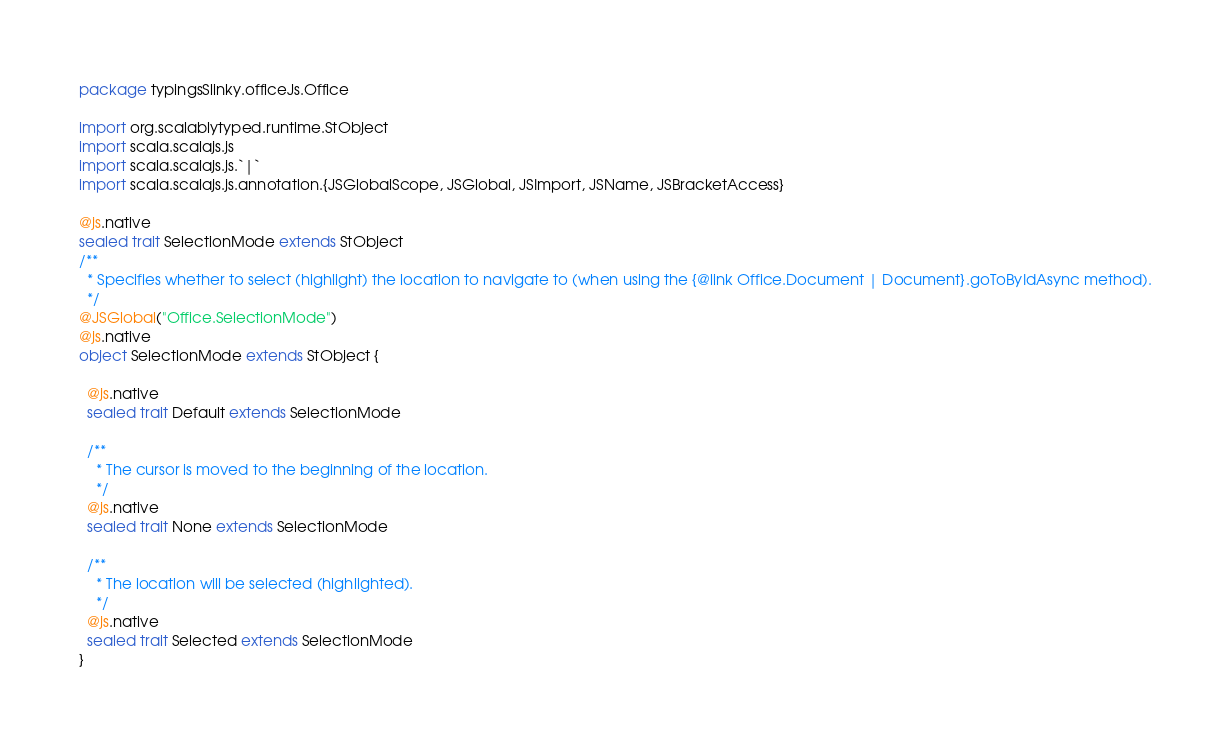Convert code to text. <code><loc_0><loc_0><loc_500><loc_500><_Scala_>package typingsSlinky.officeJs.Office

import org.scalablytyped.runtime.StObject
import scala.scalajs.js
import scala.scalajs.js.`|`
import scala.scalajs.js.annotation.{JSGlobalScope, JSGlobal, JSImport, JSName, JSBracketAccess}

@js.native
sealed trait SelectionMode extends StObject
/**
  * Specifies whether to select (highlight) the location to navigate to (when using the {@link Office.Document | Document}.goToByIdAsync method).
  */
@JSGlobal("Office.SelectionMode")
@js.native
object SelectionMode extends StObject {
  
  @js.native
  sealed trait Default extends SelectionMode
  
  /**
    * The cursor is moved to the beginning of the location.
    */
  @js.native
  sealed trait None extends SelectionMode
  
  /**
    * The location will be selected (highlighted).
    */
  @js.native
  sealed trait Selected extends SelectionMode
}
</code> 